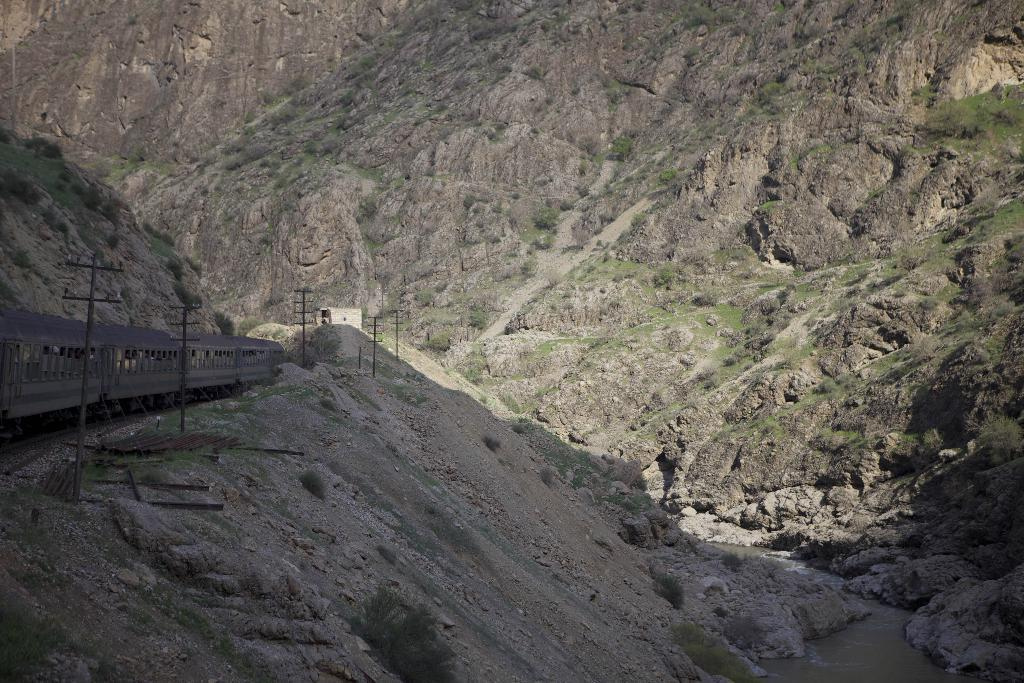What is the main subject of the image? The main subject of the image is a train. What can be seen on the ground near the train? There are rods on the ground. What structures are visible in the image? Electric poles are visible in the image. What natural features can be seen in the background of the image? A river is flowing between mountains in the image. What type of vegetation is present in the image? There are plants and grass in the image. What type of horn can be heard coming from the train in the image? There is no sound present in the image, so it is not possible to determine if a horn can be heard. 